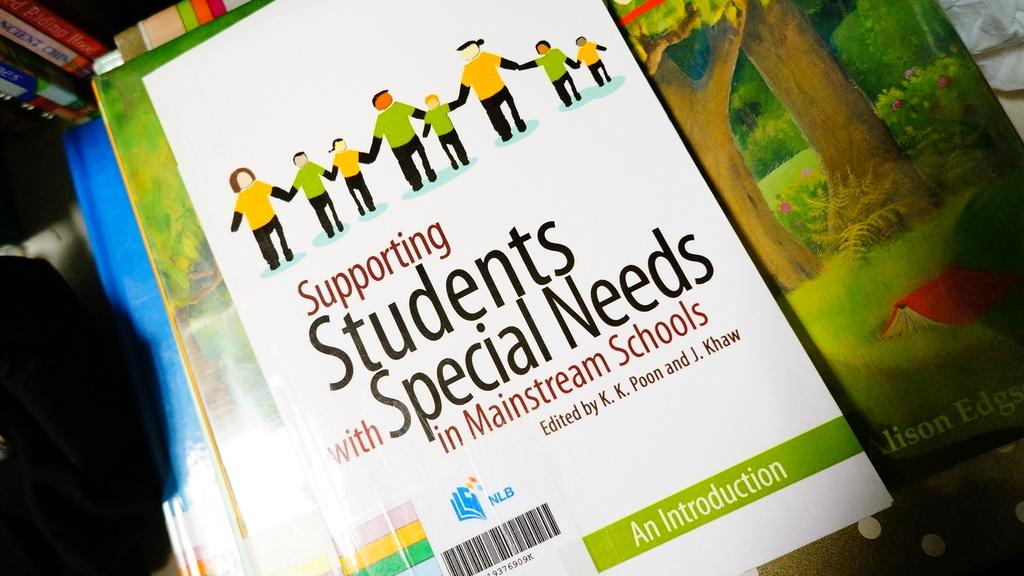<image>
Summarize the visual content of the image. book on supporting student special needs for a teacher 